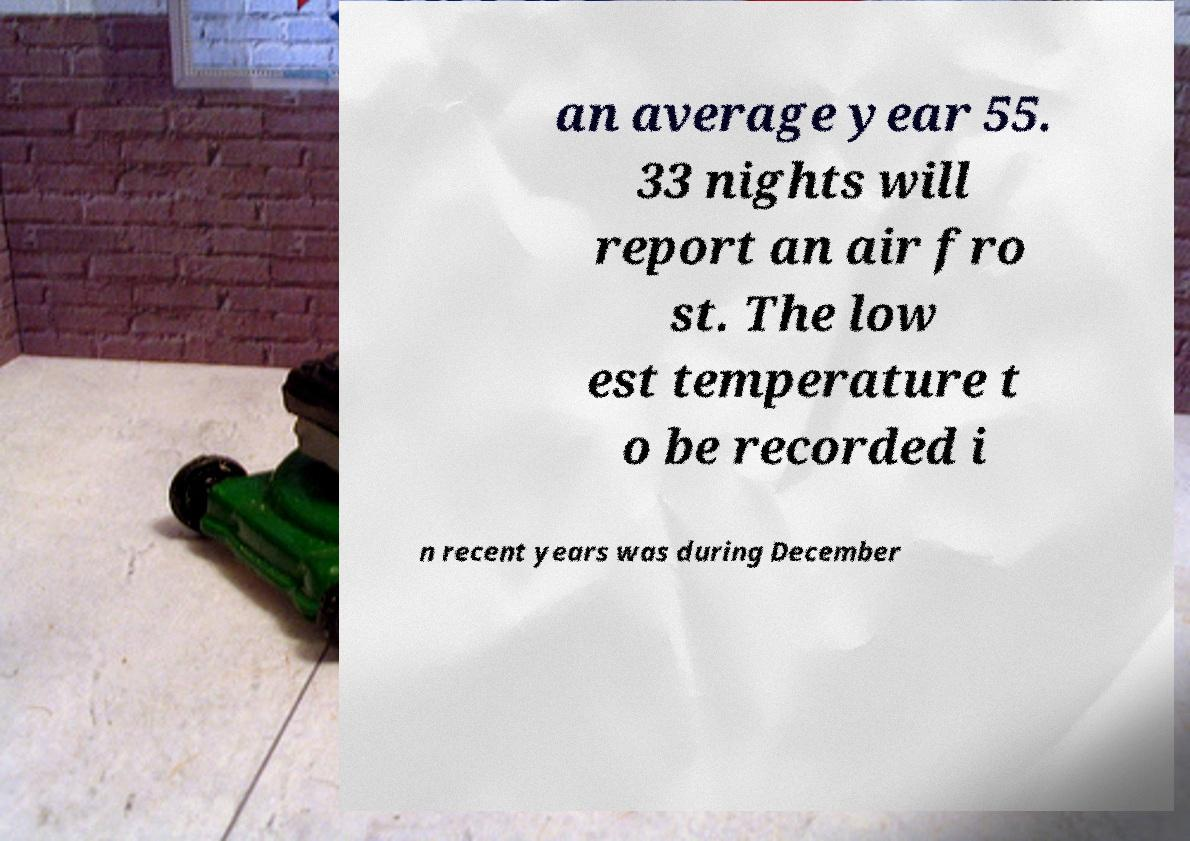Can you read and provide the text displayed in the image?This photo seems to have some interesting text. Can you extract and type it out for me? an average year 55. 33 nights will report an air fro st. The low est temperature t o be recorded i n recent years was during December 